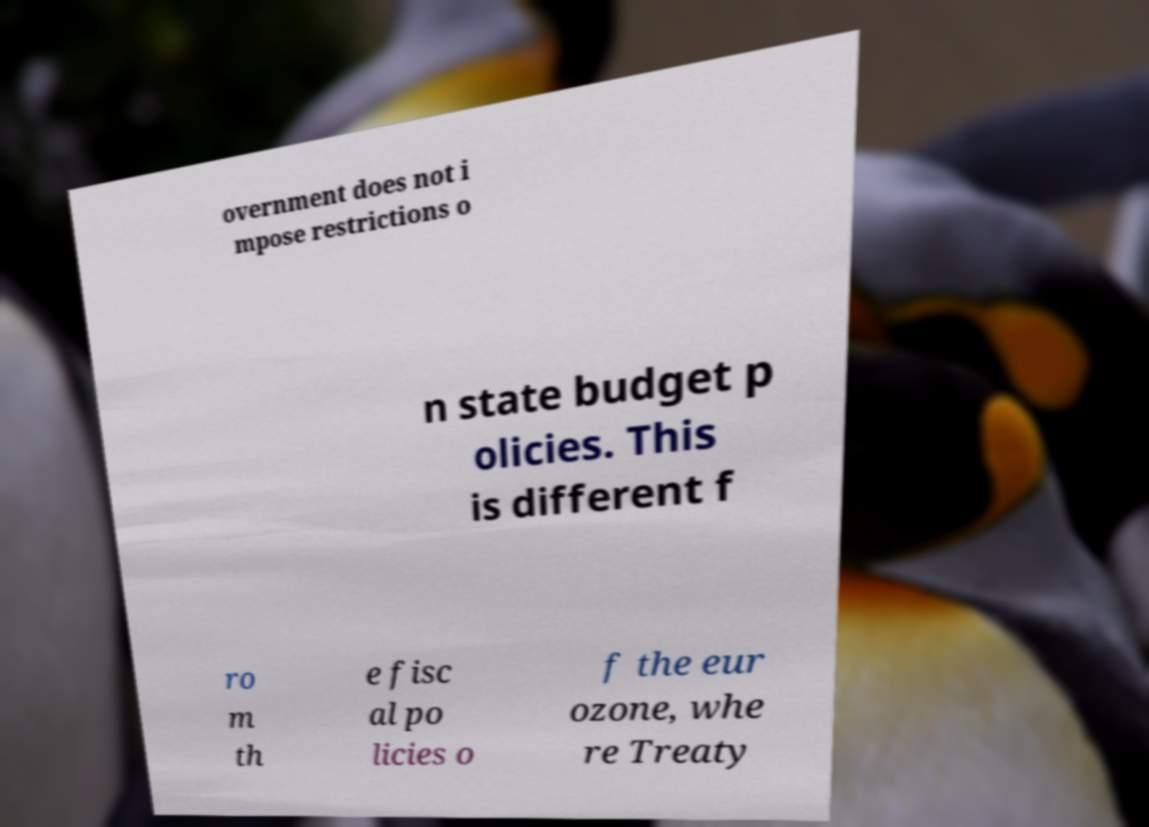Could you assist in decoding the text presented in this image and type it out clearly? overnment does not i mpose restrictions o n state budget p olicies. This is different f ro m th e fisc al po licies o f the eur ozone, whe re Treaty 